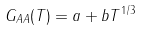<formula> <loc_0><loc_0><loc_500><loc_500>G _ { A A } ( T ) = a + b T ^ { 1 / 3 }</formula> 